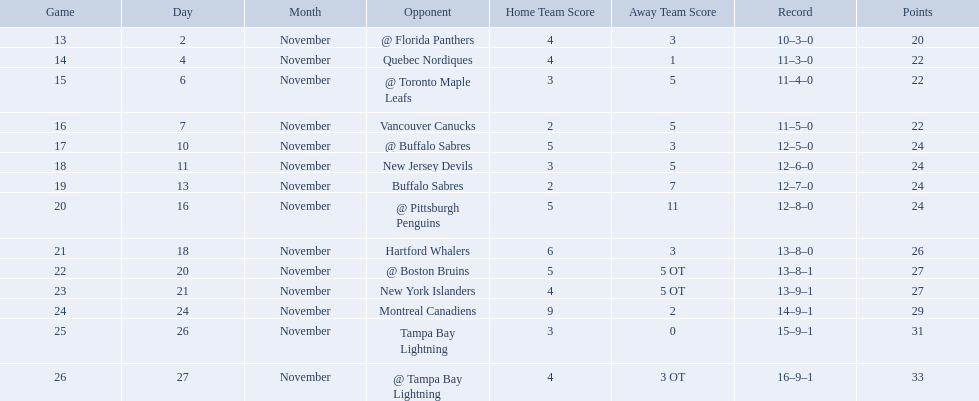Which teams scored 35 points or more in total? Hartford Whalers, @ Boston Bruins, New York Islanders, Montreal Canadiens, Tampa Bay Lightning, @ Tampa Bay Lightning. Of those teams, which team was the only one to score 3-0? Tampa Bay Lightning. What were the scores of the 1993-94 philadelphia flyers season? 4–3, 4–1, 3–5, 2–5, 5–3, 3–5, 2–7, 5–11, 6–3, 5–5 OT, 4–5 OT, 9–2, 3–0, 4–3 OT. Which of these teams had the score 4-5 ot? New York Islanders. What were the scores? @ Florida Panthers, 4–3, Quebec Nordiques, 4–1, @ Toronto Maple Leafs, 3–5, Vancouver Canucks, 2–5, @ Buffalo Sabres, 5–3, New Jersey Devils, 3–5, Buffalo Sabres, 2–7, @ Pittsburgh Penguins, 5–11, Hartford Whalers, 6–3, @ Boston Bruins, 5–5 OT, New York Islanders, 4–5 OT, Montreal Canadiens, 9–2, Tampa Bay Lightning, 3–0, @ Tampa Bay Lightning, 4–3 OT. What score was the closest? New York Islanders, 4–5 OT. What team had that score? New York Islanders. 